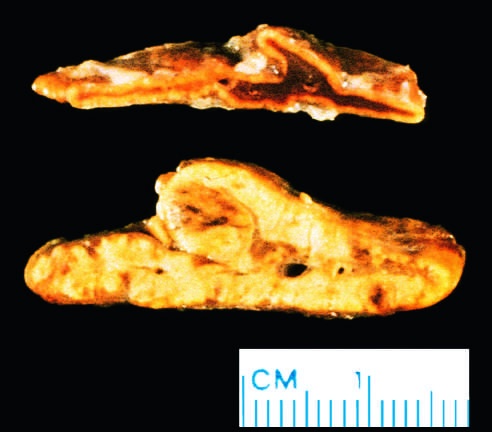what was from a patient with acth-dependent cushing syndrome, in whom both adrenal glands were diffusely hyperplastic?
Answer the question using a single word or phrase. The adnormal gland 